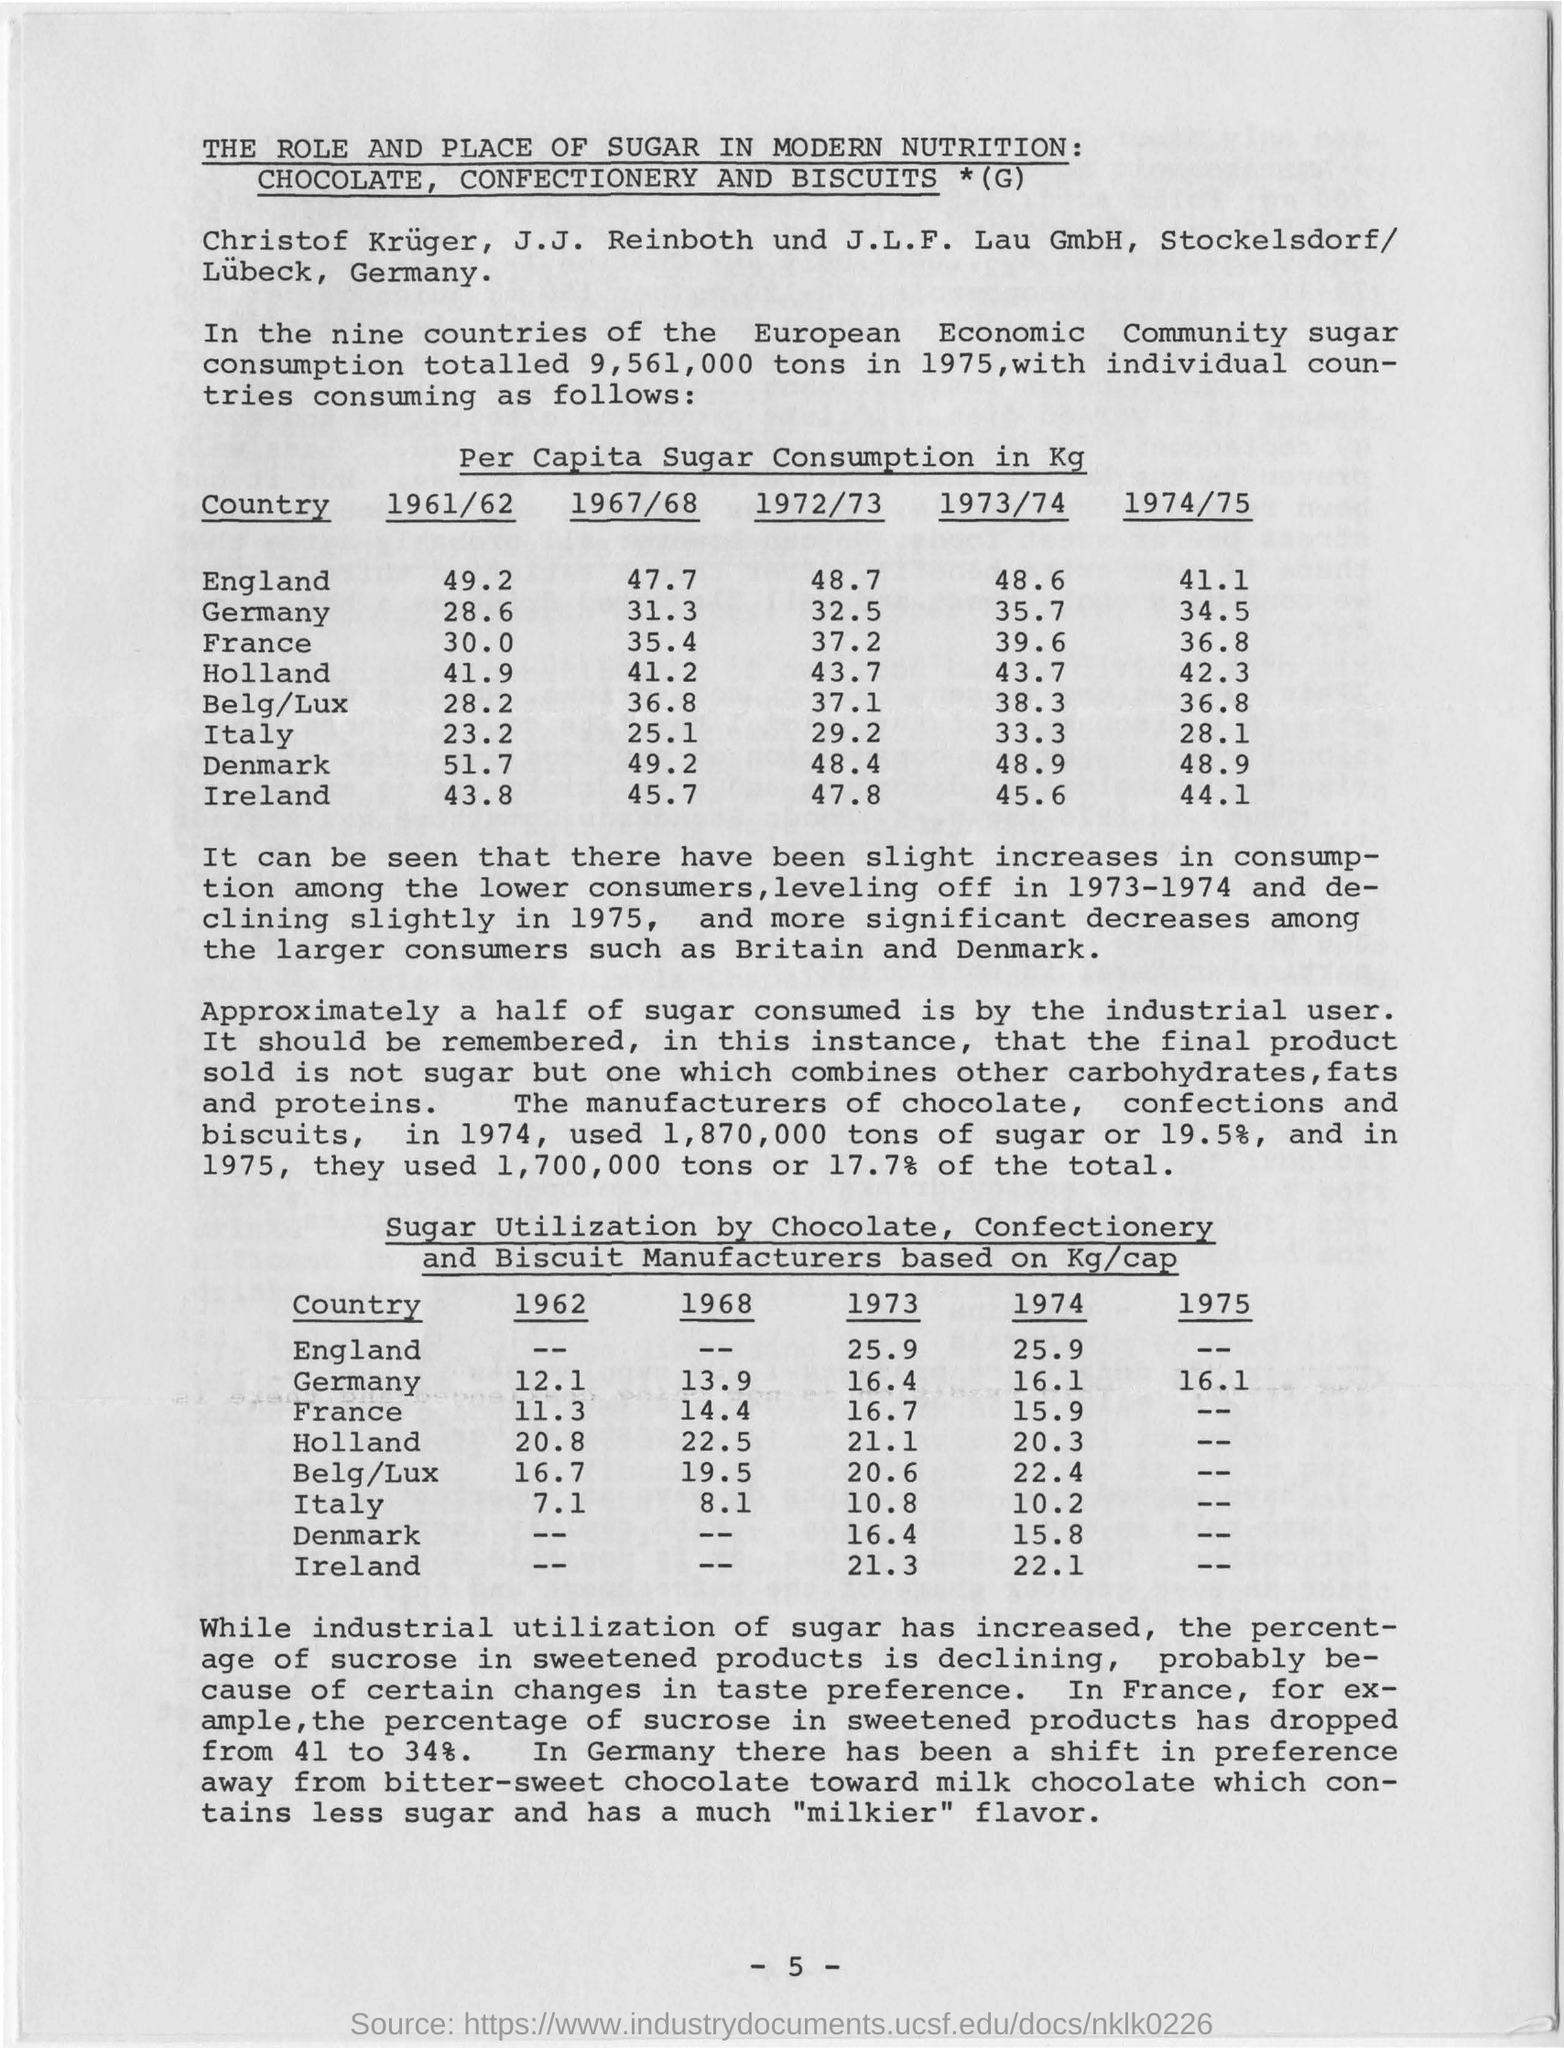Identify some key points in this picture. The sugar utilization in Germany during the year 1968 was 13.9 kilograms per capita. In the year 1972/73, Italy had the lowest per capita sugar consumption in comparison to other countries, with a consumption rate of approximately 8 kilograms per person. In 1961/62, the per capita sugar consumption in England was 49.2 kilograms. In the year 1974/75, the highest per capita sugar consumption was recorded at 48.9 kilograms. 